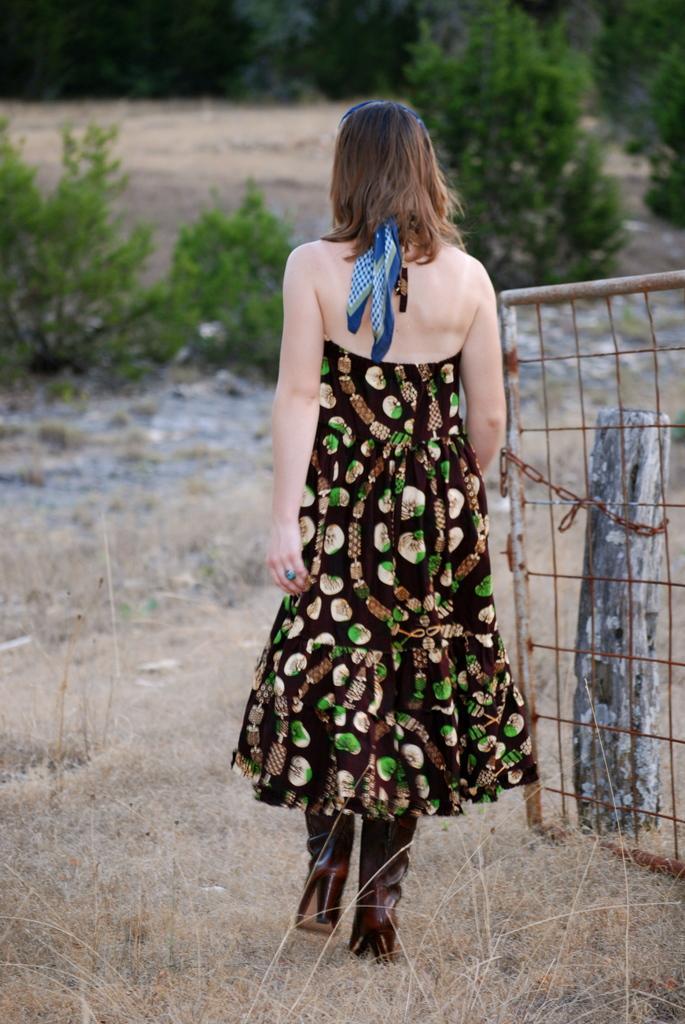Please provide a concise description of this image. In this image we can see a lady. Also there is a gate with a chain. In the back there are trees. On the ground there is grass. 